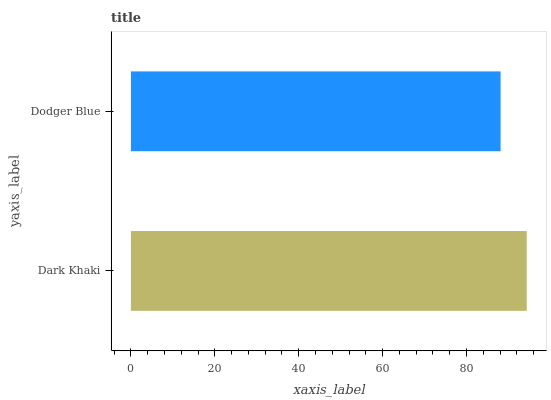Is Dodger Blue the minimum?
Answer yes or no. Yes. Is Dark Khaki the maximum?
Answer yes or no. Yes. Is Dodger Blue the maximum?
Answer yes or no. No. Is Dark Khaki greater than Dodger Blue?
Answer yes or no. Yes. Is Dodger Blue less than Dark Khaki?
Answer yes or no. Yes. Is Dodger Blue greater than Dark Khaki?
Answer yes or no. No. Is Dark Khaki less than Dodger Blue?
Answer yes or no. No. Is Dark Khaki the high median?
Answer yes or no. Yes. Is Dodger Blue the low median?
Answer yes or no. Yes. Is Dodger Blue the high median?
Answer yes or no. No. Is Dark Khaki the low median?
Answer yes or no. No. 